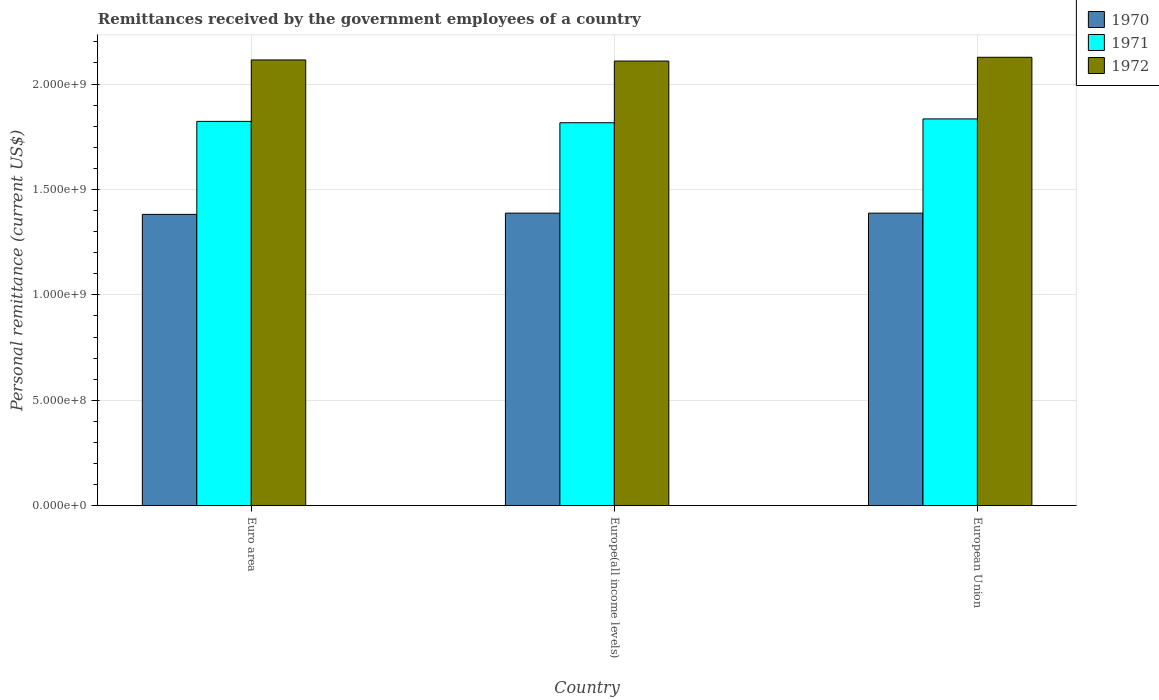What is the label of the 3rd group of bars from the left?
Your answer should be compact. European Union. In how many cases, is the number of bars for a given country not equal to the number of legend labels?
Offer a terse response. 0. What is the remittances received by the government employees in 1970 in Europe(all income levels)?
Provide a short and direct response. 1.39e+09. Across all countries, what is the maximum remittances received by the government employees in 1971?
Make the answer very short. 1.83e+09. Across all countries, what is the minimum remittances received by the government employees in 1970?
Your answer should be very brief. 1.38e+09. In which country was the remittances received by the government employees in 1970 maximum?
Your answer should be compact. Europe(all income levels). In which country was the remittances received by the government employees in 1971 minimum?
Your response must be concise. Europe(all income levels). What is the total remittances received by the government employees in 1972 in the graph?
Your answer should be very brief. 6.35e+09. What is the difference between the remittances received by the government employees in 1971 in Euro area and that in European Union?
Make the answer very short. -1.17e+07. What is the difference between the remittances received by the government employees in 1970 in European Union and the remittances received by the government employees in 1972 in Europe(all income levels)?
Your response must be concise. -7.21e+08. What is the average remittances received by the government employees in 1972 per country?
Your answer should be compact. 2.12e+09. What is the difference between the remittances received by the government employees of/in 1971 and remittances received by the government employees of/in 1970 in Euro area?
Ensure brevity in your answer.  4.41e+08. What is the ratio of the remittances received by the government employees in 1972 in Euro area to that in Europe(all income levels)?
Ensure brevity in your answer.  1. What is the difference between the highest and the second highest remittances received by the government employees in 1970?
Keep it short and to the point. -5.80e+06. What is the difference between the highest and the lowest remittances received by the government employees in 1970?
Offer a terse response. 5.80e+06. What does the 1st bar from the right in European Union represents?
Your response must be concise. 1972. Is it the case that in every country, the sum of the remittances received by the government employees in 1970 and remittances received by the government employees in 1972 is greater than the remittances received by the government employees in 1971?
Offer a very short reply. Yes. What is the difference between two consecutive major ticks on the Y-axis?
Provide a short and direct response. 5.00e+08. Does the graph contain any zero values?
Make the answer very short. No. Where does the legend appear in the graph?
Offer a very short reply. Top right. What is the title of the graph?
Keep it short and to the point. Remittances received by the government employees of a country. What is the label or title of the X-axis?
Make the answer very short. Country. What is the label or title of the Y-axis?
Provide a short and direct response. Personal remittance (current US$). What is the Personal remittance (current US$) of 1970 in Euro area?
Offer a very short reply. 1.38e+09. What is the Personal remittance (current US$) in 1971 in Euro area?
Your response must be concise. 1.82e+09. What is the Personal remittance (current US$) of 1972 in Euro area?
Give a very brief answer. 2.11e+09. What is the Personal remittance (current US$) of 1970 in Europe(all income levels)?
Offer a terse response. 1.39e+09. What is the Personal remittance (current US$) of 1971 in Europe(all income levels)?
Ensure brevity in your answer.  1.82e+09. What is the Personal remittance (current US$) of 1972 in Europe(all income levels)?
Keep it short and to the point. 2.11e+09. What is the Personal remittance (current US$) in 1970 in European Union?
Keep it short and to the point. 1.39e+09. What is the Personal remittance (current US$) in 1971 in European Union?
Make the answer very short. 1.83e+09. What is the Personal remittance (current US$) of 1972 in European Union?
Give a very brief answer. 2.13e+09. Across all countries, what is the maximum Personal remittance (current US$) of 1970?
Offer a terse response. 1.39e+09. Across all countries, what is the maximum Personal remittance (current US$) of 1971?
Offer a very short reply. 1.83e+09. Across all countries, what is the maximum Personal remittance (current US$) in 1972?
Give a very brief answer. 2.13e+09. Across all countries, what is the minimum Personal remittance (current US$) in 1970?
Your answer should be compact. 1.38e+09. Across all countries, what is the minimum Personal remittance (current US$) of 1971?
Provide a succinct answer. 1.82e+09. Across all countries, what is the minimum Personal remittance (current US$) of 1972?
Ensure brevity in your answer.  2.11e+09. What is the total Personal remittance (current US$) of 1970 in the graph?
Your answer should be very brief. 4.16e+09. What is the total Personal remittance (current US$) of 1971 in the graph?
Offer a very short reply. 5.47e+09. What is the total Personal remittance (current US$) in 1972 in the graph?
Your answer should be very brief. 6.35e+09. What is the difference between the Personal remittance (current US$) of 1970 in Euro area and that in Europe(all income levels)?
Provide a succinct answer. -5.80e+06. What is the difference between the Personal remittance (current US$) in 1971 in Euro area and that in Europe(all income levels)?
Keep it short and to the point. 6.47e+06. What is the difference between the Personal remittance (current US$) of 1972 in Euro area and that in Europe(all income levels)?
Make the answer very short. 5.22e+06. What is the difference between the Personal remittance (current US$) of 1970 in Euro area and that in European Union?
Provide a succinct answer. -5.80e+06. What is the difference between the Personal remittance (current US$) in 1971 in Euro area and that in European Union?
Give a very brief answer. -1.17e+07. What is the difference between the Personal remittance (current US$) in 1972 in Euro area and that in European Union?
Make the answer very short. -1.26e+07. What is the difference between the Personal remittance (current US$) in 1971 in Europe(all income levels) and that in European Union?
Ensure brevity in your answer.  -1.82e+07. What is the difference between the Personal remittance (current US$) in 1972 in Europe(all income levels) and that in European Union?
Provide a short and direct response. -1.78e+07. What is the difference between the Personal remittance (current US$) of 1970 in Euro area and the Personal remittance (current US$) of 1971 in Europe(all income levels)?
Offer a very short reply. -4.35e+08. What is the difference between the Personal remittance (current US$) of 1970 in Euro area and the Personal remittance (current US$) of 1972 in Europe(all income levels)?
Offer a very short reply. -7.27e+08. What is the difference between the Personal remittance (current US$) of 1971 in Euro area and the Personal remittance (current US$) of 1972 in Europe(all income levels)?
Provide a succinct answer. -2.86e+08. What is the difference between the Personal remittance (current US$) of 1970 in Euro area and the Personal remittance (current US$) of 1971 in European Union?
Offer a very short reply. -4.53e+08. What is the difference between the Personal remittance (current US$) in 1970 in Euro area and the Personal remittance (current US$) in 1972 in European Union?
Your answer should be compact. -7.45e+08. What is the difference between the Personal remittance (current US$) of 1971 in Euro area and the Personal remittance (current US$) of 1972 in European Union?
Make the answer very short. -3.04e+08. What is the difference between the Personal remittance (current US$) in 1970 in Europe(all income levels) and the Personal remittance (current US$) in 1971 in European Union?
Offer a terse response. -4.47e+08. What is the difference between the Personal remittance (current US$) of 1970 in Europe(all income levels) and the Personal remittance (current US$) of 1972 in European Union?
Make the answer very short. -7.39e+08. What is the difference between the Personal remittance (current US$) of 1971 in Europe(all income levels) and the Personal remittance (current US$) of 1972 in European Union?
Your response must be concise. -3.10e+08. What is the average Personal remittance (current US$) of 1970 per country?
Provide a short and direct response. 1.39e+09. What is the average Personal remittance (current US$) in 1971 per country?
Provide a short and direct response. 1.82e+09. What is the average Personal remittance (current US$) of 1972 per country?
Offer a very short reply. 2.12e+09. What is the difference between the Personal remittance (current US$) in 1970 and Personal remittance (current US$) in 1971 in Euro area?
Provide a short and direct response. -4.41e+08. What is the difference between the Personal remittance (current US$) in 1970 and Personal remittance (current US$) in 1972 in Euro area?
Offer a terse response. -7.32e+08. What is the difference between the Personal remittance (current US$) in 1971 and Personal remittance (current US$) in 1972 in Euro area?
Offer a very short reply. -2.91e+08. What is the difference between the Personal remittance (current US$) of 1970 and Personal remittance (current US$) of 1971 in Europe(all income levels)?
Your response must be concise. -4.29e+08. What is the difference between the Personal remittance (current US$) of 1970 and Personal remittance (current US$) of 1972 in Europe(all income levels)?
Offer a very short reply. -7.21e+08. What is the difference between the Personal remittance (current US$) in 1971 and Personal remittance (current US$) in 1972 in Europe(all income levels)?
Give a very brief answer. -2.93e+08. What is the difference between the Personal remittance (current US$) in 1970 and Personal remittance (current US$) in 1971 in European Union?
Your answer should be compact. -4.47e+08. What is the difference between the Personal remittance (current US$) of 1970 and Personal remittance (current US$) of 1972 in European Union?
Offer a terse response. -7.39e+08. What is the difference between the Personal remittance (current US$) in 1971 and Personal remittance (current US$) in 1972 in European Union?
Provide a short and direct response. -2.92e+08. What is the ratio of the Personal remittance (current US$) of 1972 in Euro area to that in Europe(all income levels)?
Your answer should be compact. 1. What is the ratio of the Personal remittance (current US$) in 1970 in Euro area to that in European Union?
Keep it short and to the point. 1. What is the ratio of the Personal remittance (current US$) in 1970 in Europe(all income levels) to that in European Union?
Provide a short and direct response. 1. What is the difference between the highest and the second highest Personal remittance (current US$) of 1970?
Give a very brief answer. 0. What is the difference between the highest and the second highest Personal remittance (current US$) of 1971?
Keep it short and to the point. 1.17e+07. What is the difference between the highest and the second highest Personal remittance (current US$) in 1972?
Keep it short and to the point. 1.26e+07. What is the difference between the highest and the lowest Personal remittance (current US$) in 1970?
Give a very brief answer. 5.80e+06. What is the difference between the highest and the lowest Personal remittance (current US$) of 1971?
Give a very brief answer. 1.82e+07. What is the difference between the highest and the lowest Personal remittance (current US$) of 1972?
Offer a very short reply. 1.78e+07. 